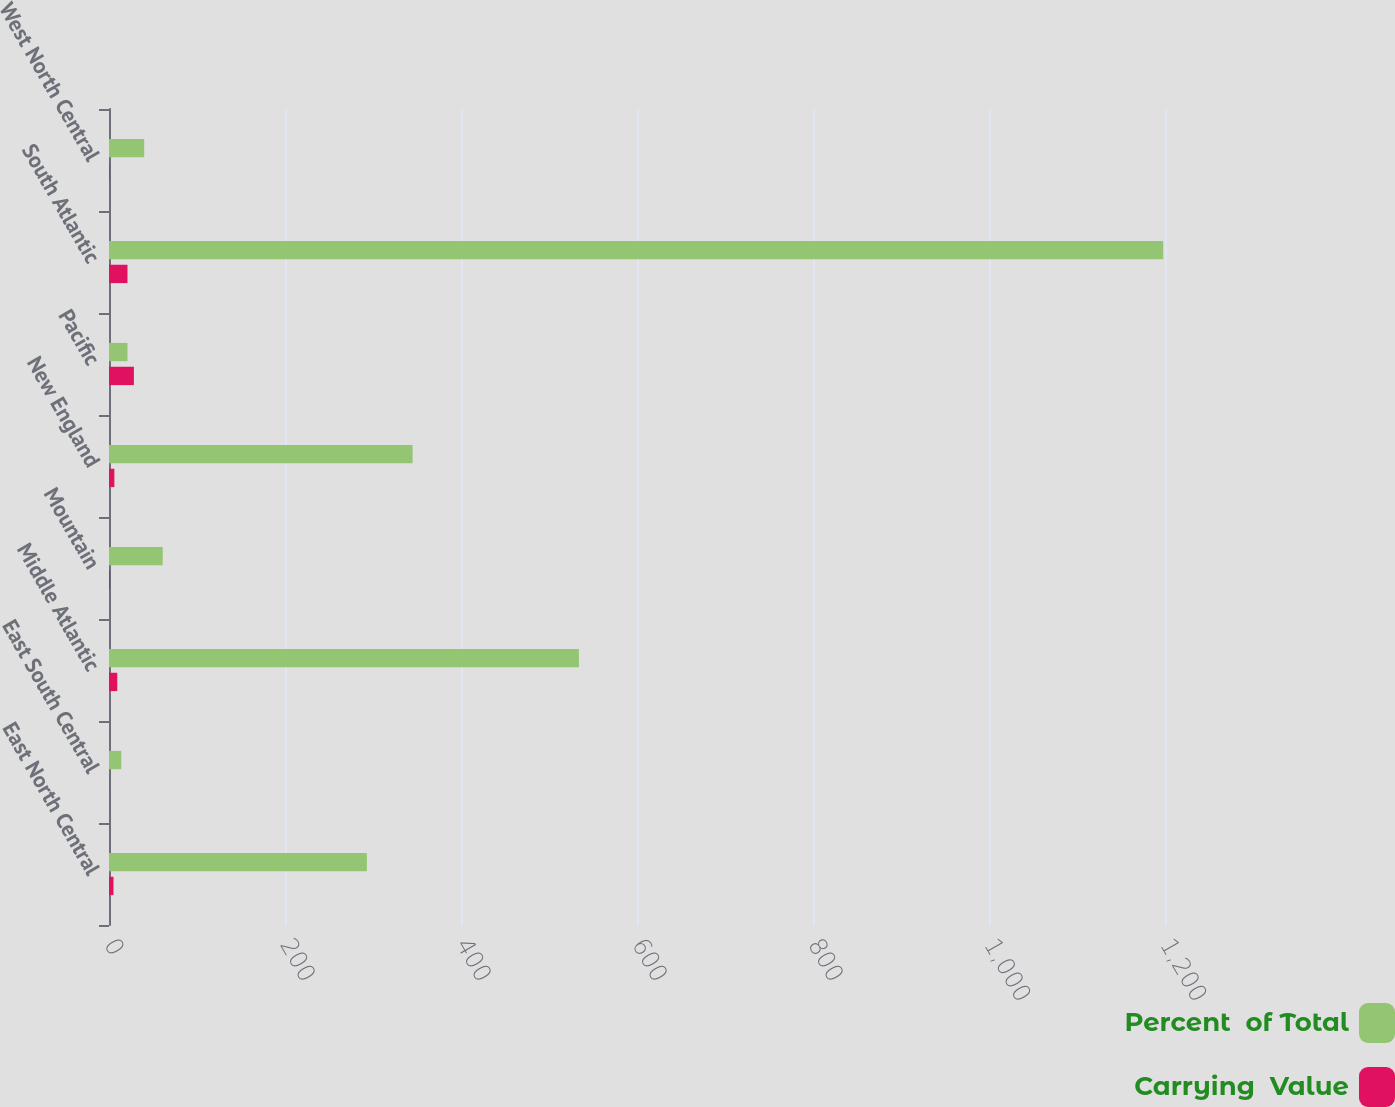Convert chart to OTSL. <chart><loc_0><loc_0><loc_500><loc_500><stacked_bar_chart><ecel><fcel>East North Central<fcel>East South Central<fcel>Middle Atlantic<fcel>Mountain<fcel>New England<fcel>Pacific<fcel>South Atlantic<fcel>West North Central<nl><fcel>Percent  of Total<fcel>293<fcel>14<fcel>534<fcel>61<fcel>345<fcel>21<fcel>1198<fcel>40<nl><fcel>Carrying  Value<fcel>5.1<fcel>0.2<fcel>9.4<fcel>1.1<fcel>6.1<fcel>28.3<fcel>21<fcel>0.7<nl></chart> 